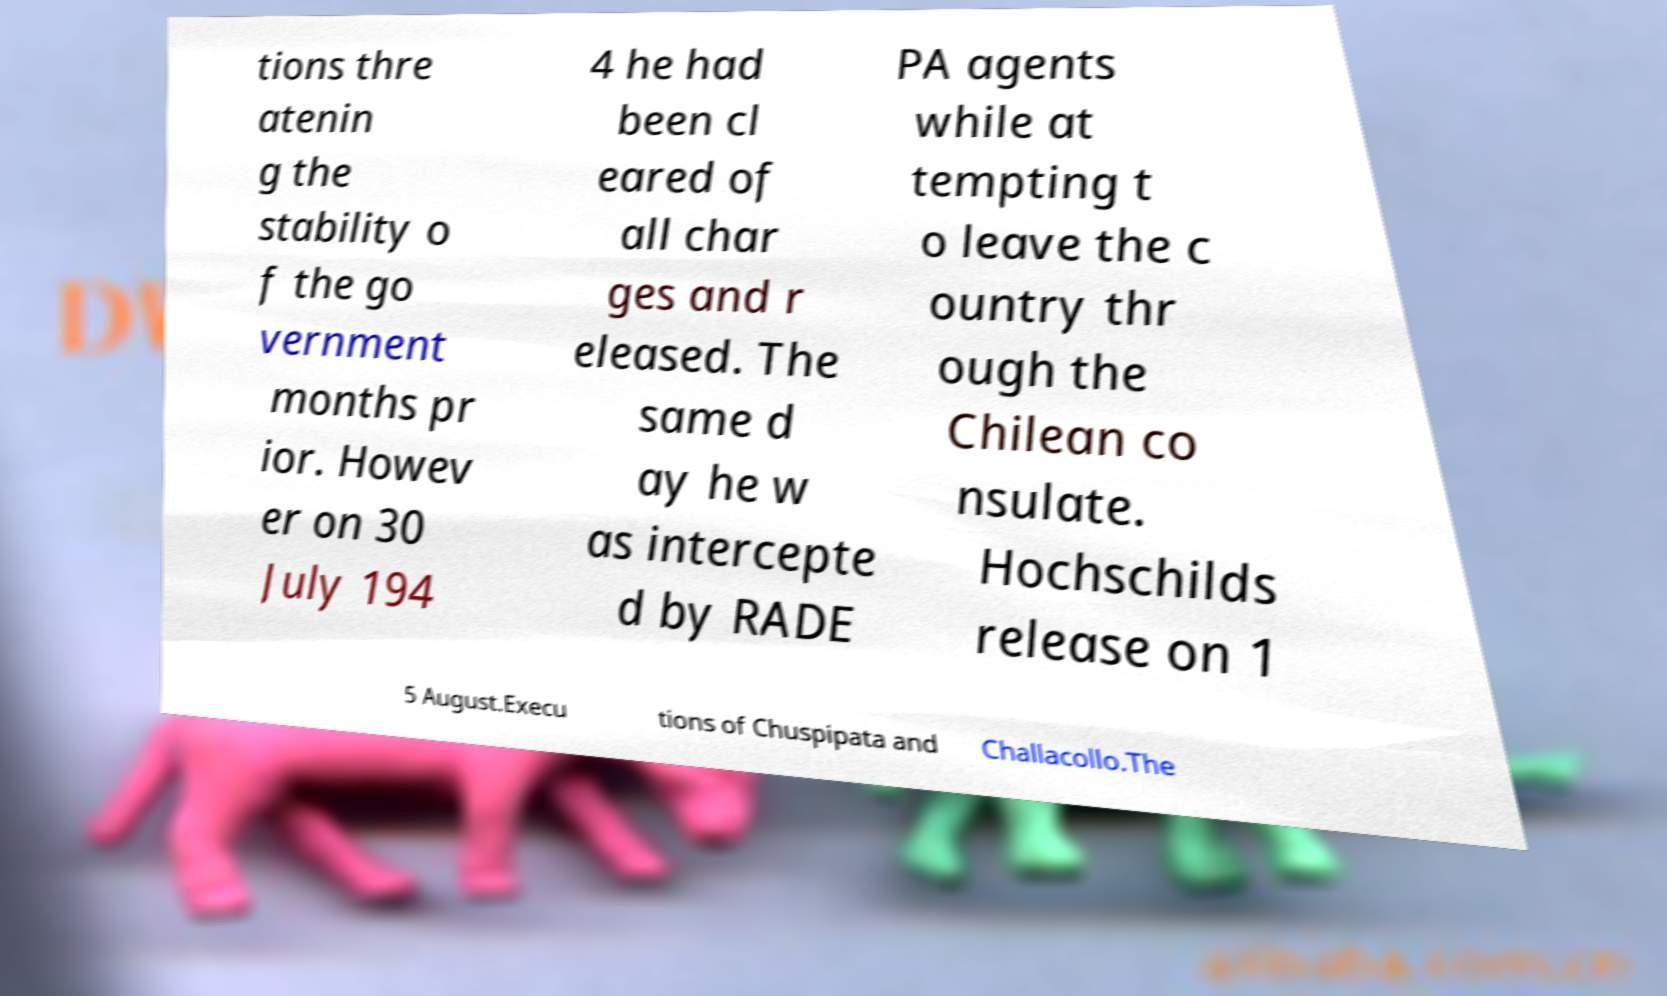I need the written content from this picture converted into text. Can you do that? tions thre atenin g the stability o f the go vernment months pr ior. Howev er on 30 July 194 4 he had been cl eared of all char ges and r eleased. The same d ay he w as intercepte d by RADE PA agents while at tempting t o leave the c ountry thr ough the Chilean co nsulate. Hochschilds release on 1 5 August.Execu tions of Chuspipata and Challacollo.The 